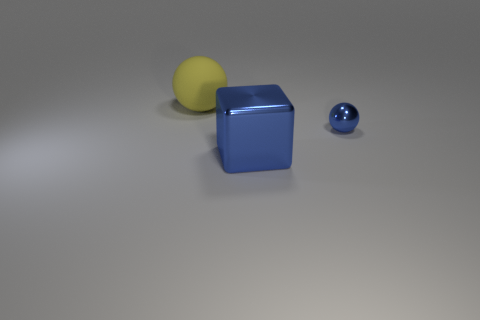Add 2 big balls. How many objects exist? 5 Subtract all spheres. How many objects are left? 1 Add 1 big blue blocks. How many big blue blocks are left? 2 Add 1 big red metal cylinders. How many big red metal cylinders exist? 1 Subtract 1 blue spheres. How many objects are left? 2 Subtract all blue cubes. Subtract all brown metallic cylinders. How many objects are left? 2 